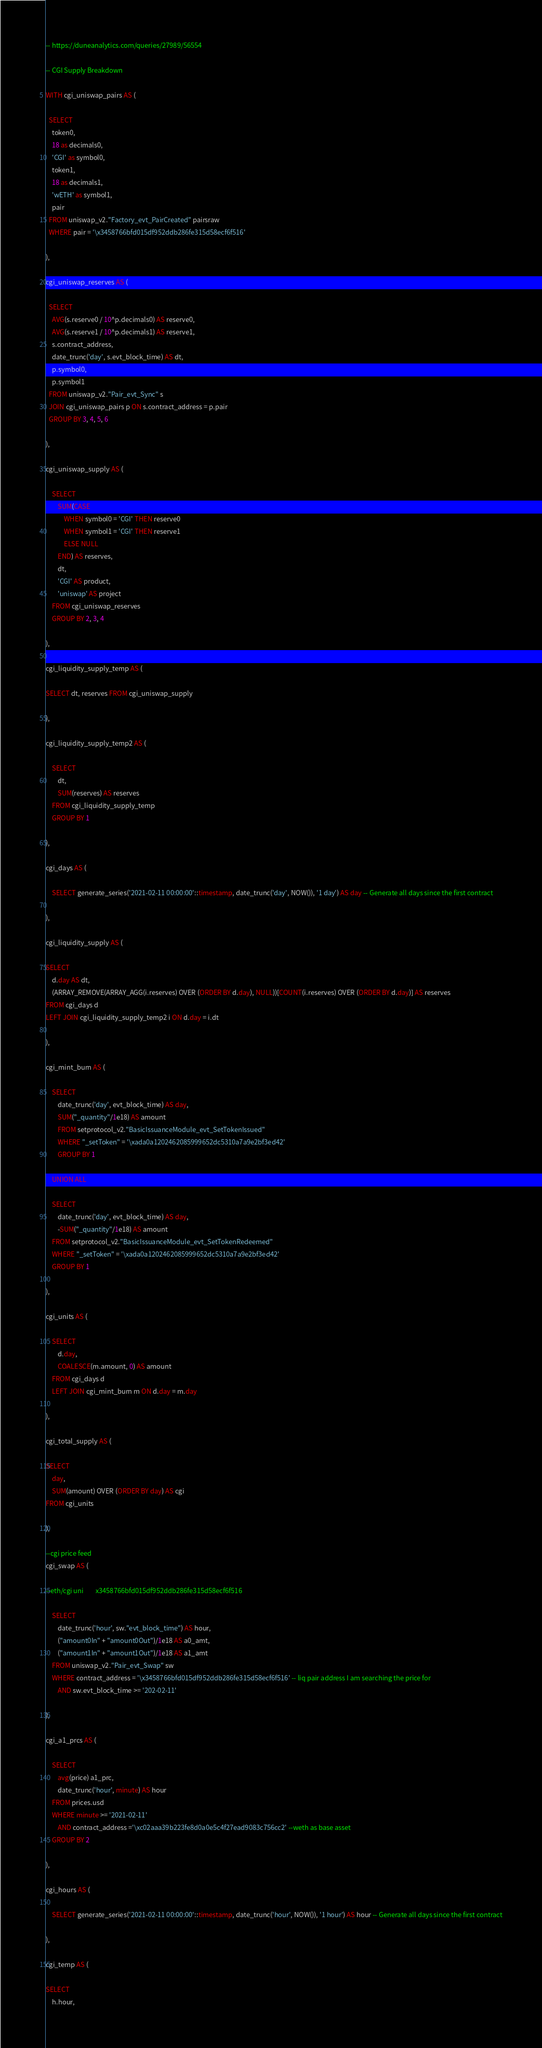Convert code to text. <code><loc_0><loc_0><loc_500><loc_500><_SQL_>-- https://duneanalytics.com/queries/27989/56554

-- CGI Supply Breakdown

WITH cgi_uniswap_pairs AS (

  SELECT
    token0,
    18 as decimals0,
    'CGI' as symbol0,
    token1,
    18 as decimals1,
    'wETH' as symbol1,
    pair
  FROM uniswap_v2."Factory_evt_PairCreated" pairsraw
  WHERE pair = '\x3458766bfd015df952ddb286fe315d58ecf6f516'
  
),

cgi_uniswap_reserves AS (

  SELECT
    AVG(s.reserve0 / 10^p.decimals0) AS reserve0,
    AVG(s.reserve1 / 10^p.decimals1) AS reserve1,
    s.contract_address,
    date_trunc('day', s.evt_block_time) AS dt,
    p.symbol0,
    p.symbol1
  FROM uniswap_v2."Pair_evt_Sync" s
  JOIN cgi_uniswap_pairs p ON s.contract_address = p.pair
  GROUP BY 3, 4, 5, 6

),

cgi_uniswap_supply AS (

    SELECT
        SUM(CASE
            WHEN symbol0 = 'CGI' THEN reserve0
            WHEN symbol1 = 'CGI' THEN reserve1
            ELSE NULL
        END) AS reserves,
        dt,
        'CGI' AS product,
        'uniswap' AS project
    FROM cgi_uniswap_reserves
    GROUP BY 2, 3, 4
 
),

cgi_liquidity_supply_temp AS (

SELECT dt, reserves FROM cgi_uniswap_supply

),

cgi_liquidity_supply_temp2 AS (

    SELECT
        dt,
        SUM(reserves) AS reserves
    FROM cgi_liquidity_supply_temp
    GROUP BY 1

),

cgi_days AS (
    
    SELECT generate_series('2021-02-11 00:00:00'::timestamp, date_trunc('day', NOW()), '1 day') AS day -- Generate all days since the first contract
    
),

cgi_liquidity_supply AS (

SELECT
    d.day AS dt,
    (ARRAY_REMOVE(ARRAY_AGG(i.reserves) OVER (ORDER BY d.day), NULL))[COUNT(i.reserves) OVER (ORDER BY d.day)] AS reserves
FROM cgi_days d
LEFT JOIN cgi_liquidity_supply_temp2 i ON d.day = i.dt

),

cgi_mint_burn AS (

    SELECT 
        date_trunc('day', evt_block_time) AS day, 
        SUM("_quantity"/1e18) AS amount 
        FROM setprotocol_v2."BasicIssuanceModule_evt_SetTokenIssued"
        WHERE "_setToken" = '\xada0a1202462085999652dc5310a7a9e2bf3ed42'
        GROUP BY 1

    UNION ALL

    SELECT 
        date_trunc('day', evt_block_time) AS day, 
        -SUM("_quantity"/1e18) AS amount 
    FROM setprotocol_v2."BasicIssuanceModule_evt_SetTokenRedeemed" 
    WHERE "_setToken" = '\xada0a1202462085999652dc5310a7a9e2bf3ed42'
    GROUP BY 1

),

cgi_units AS (

    SELECT
        d.day,
        COALESCE(m.amount, 0) AS amount
    FROM cgi_days d
    LEFT JOIN cgi_mint_burn m ON d.day = m.day
    
),

cgi_total_supply AS (

SELECT 
    day, 
    SUM(amount) OVER (ORDER BY day) AS cgi
FROM cgi_units

),

--cgi price feed
cgi_swap AS (

--eth/cgi uni        x3458766bfd015df952ddb286fe315d58ecf6f516
    
    SELECT
        date_trunc('hour', sw."evt_block_time") AS hour,
        ("amount0In" + "amount0Out")/1e18 AS a0_amt, 
        ("amount1In" + "amount1Out")/1e18 AS a1_amt
    FROM uniswap_v2."Pair_evt_Swap" sw
    WHERE contract_address = '\x3458766bfd015df952ddb286fe315d58ecf6f516' -- liq pair address I am searching the price for
        AND sw.evt_block_time >= '202-02-11'

),

cgi_a1_prcs AS (

    SELECT 
        avg(price) a1_prc, 
        date_trunc('hour', minute) AS hour
    FROM prices.usd
    WHERE minute >= '2021-02-11'
        AND contract_address ='\xc02aaa39b223fe8d0a0e5c4f27ead9083c756cc2' --weth as base asset
    GROUP BY 2
                
),

cgi_hours AS (
    
    SELECT generate_series('2021-02-11 00:00:00'::timestamp, date_trunc('hour', NOW()), '1 hour') AS hour -- Generate all days since the first contract
    
),

cgi_temp AS (

SELECT
    h.hour,</code> 